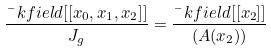<formula> <loc_0><loc_0><loc_500><loc_500>\frac { \bar { \ } k f i e l d [ [ x _ { 0 } , x _ { 1 } , x _ { 2 } ] ] } { J _ { g } } = \frac { \bar { \ } k f i e l d [ [ x _ { 2 } ] ] } { ( A ( x _ { 2 } ) ) }</formula> 